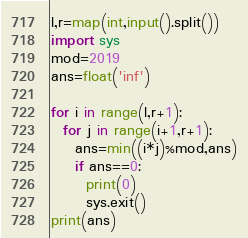Convert code to text. <code><loc_0><loc_0><loc_500><loc_500><_Python_>l,r=map(int,input().split())
import sys
mod=2019
ans=float('inf')

for i in range(l,r+1):
  for j in range(i+1,r+1):
    ans=min((i*j)%mod,ans)
    if ans==0:
      print(0)
      sys.exit()
print(ans)</code> 